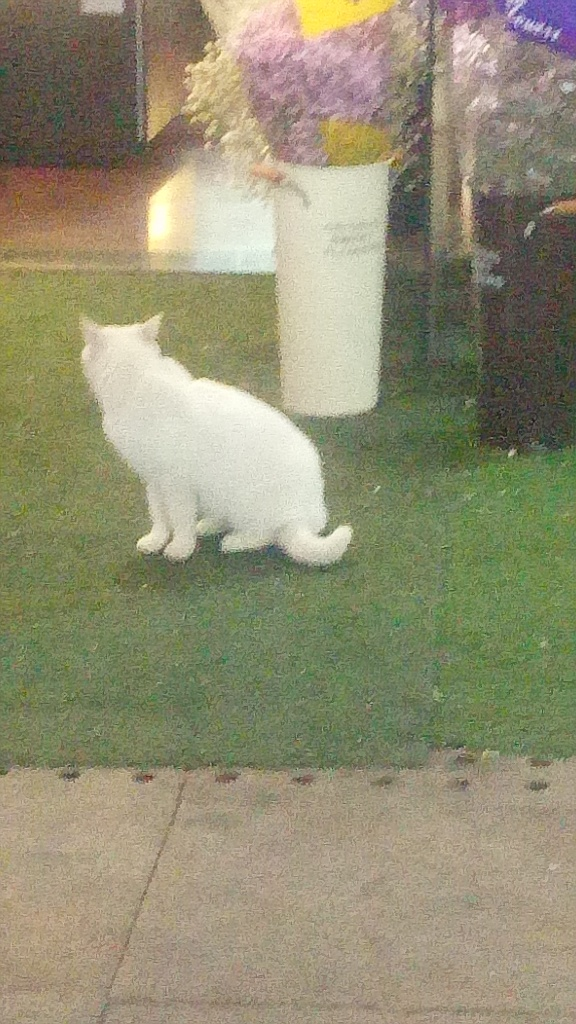What is the average level of details and texture in the cat and flower?
A. extraordinary
B. excellent
C. average
Answer with the option's letter from the given choices directly. Based on the quality of the image provided, the detail and texture of both the cat and the flowers are not entirely discernible. The overall level of detail and texture for the cat and the flower can be considered around average, due to the image's blurriness and lack of clarity. Therefore, the most accurate answer is C. average. 